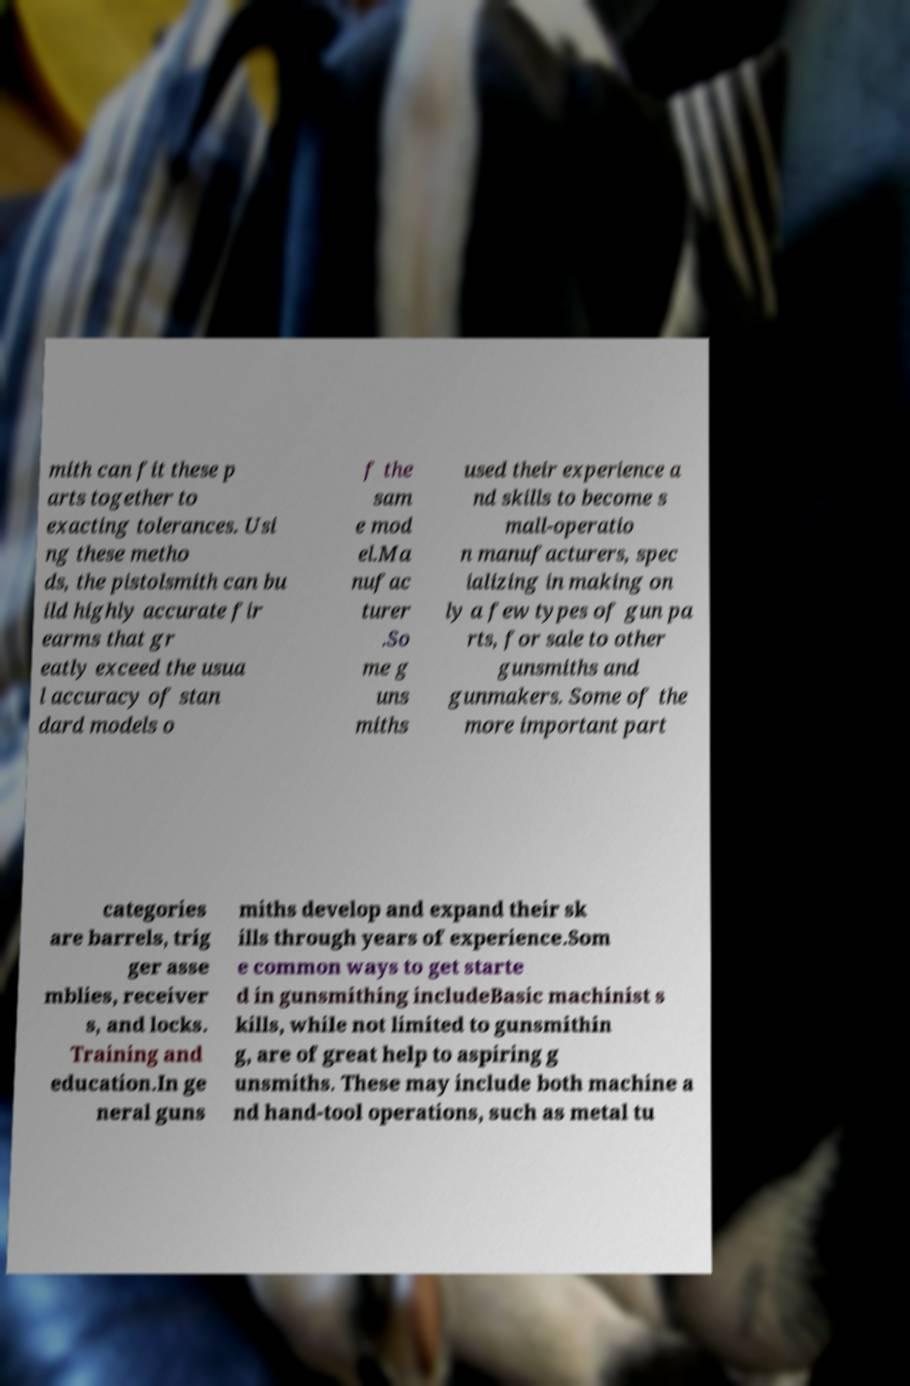Could you extract and type out the text from this image? mith can fit these p arts together to exacting tolerances. Usi ng these metho ds, the pistolsmith can bu ild highly accurate fir earms that gr eatly exceed the usua l accuracy of stan dard models o f the sam e mod el.Ma nufac turer .So me g uns miths used their experience a nd skills to become s mall-operatio n manufacturers, spec ializing in making on ly a few types of gun pa rts, for sale to other gunsmiths and gunmakers. Some of the more important part categories are barrels, trig ger asse mblies, receiver s, and locks. Training and education.In ge neral guns miths develop and expand their sk ills through years of experience.Som e common ways to get starte d in gunsmithing includeBasic machinist s kills, while not limited to gunsmithin g, are of great help to aspiring g unsmiths. These may include both machine a nd hand-tool operations, such as metal tu 